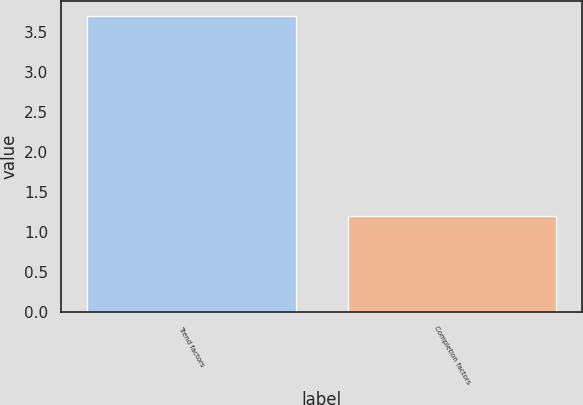<chart> <loc_0><loc_0><loc_500><loc_500><bar_chart><fcel>Trend factors<fcel>Completion factors<nl><fcel>3.7<fcel>1.2<nl></chart> 